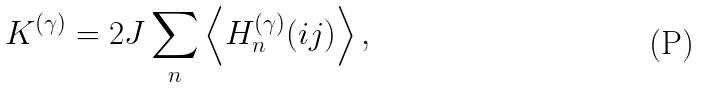<formula> <loc_0><loc_0><loc_500><loc_500>K ^ { ( \gamma ) } = 2 J \sum _ { n } \left \langle H _ { n } ^ { ( \gamma ) } ( i j ) \right \rangle ,</formula> 